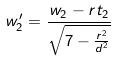<formula> <loc_0><loc_0><loc_500><loc_500>w _ { 2 } ^ { \prime } = \frac { w _ { 2 } - r t _ { 2 } } { \sqrt { 7 - \frac { r ^ { 2 } } { d ^ { 2 } } } }</formula> 